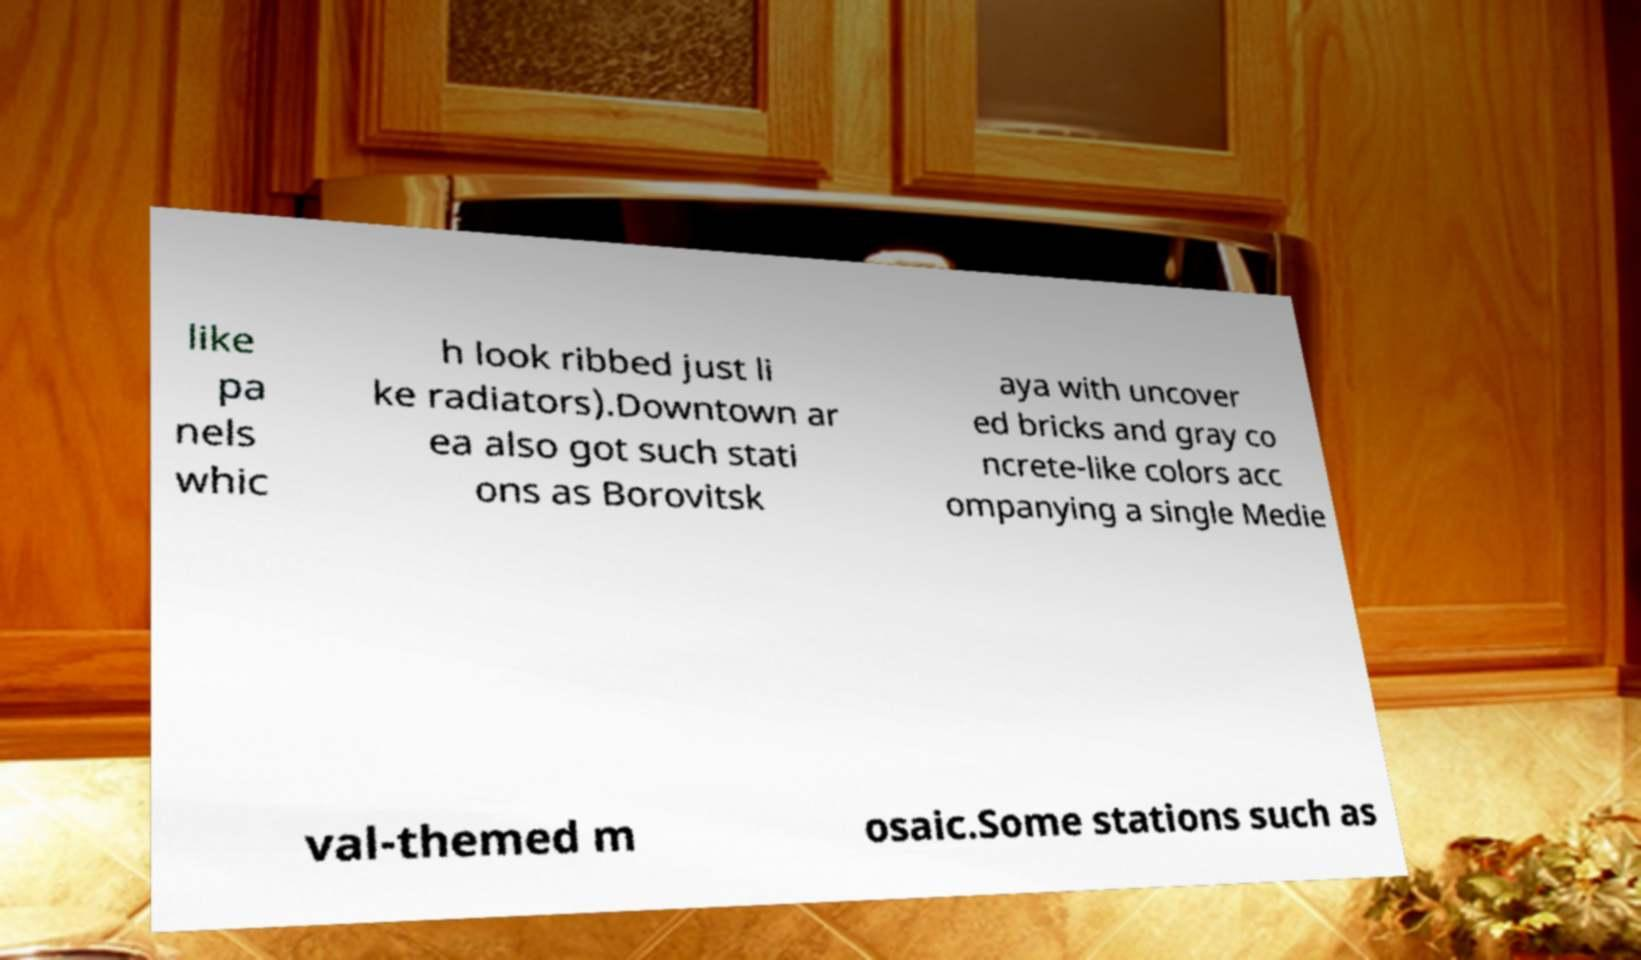For documentation purposes, I need the text within this image transcribed. Could you provide that? like pa nels whic h look ribbed just li ke radiators).Downtown ar ea also got such stati ons as Borovitsk aya with uncover ed bricks and gray co ncrete-like colors acc ompanying a single Medie val-themed m osaic.Some stations such as 